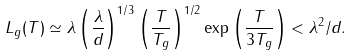<formula> <loc_0><loc_0><loc_500><loc_500>L _ { g } ( T ) \simeq \lambda \left ( \frac { \lambda } { d } \right ) ^ { 1 / 3 } \left ( \frac { T } { T _ { g } } \right ) ^ { 1 / 2 } \exp \left ( \frac { T } { 3 T _ { g } } \right ) < \lambda ^ { 2 } / d .</formula> 